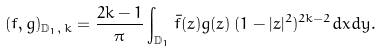<formula> <loc_0><loc_0><loc_500><loc_500>( f , g ) _ { \mathbb { D } _ { 1 } , \, k } = \frac { 2 k - 1 } { \pi } \int _ { \mathbb { D } _ { 1 } } \bar { f } ( z ) g ( z ) \, ( 1 - | z | ^ { 2 } ) ^ { 2 k - 2 } d x d y .</formula> 